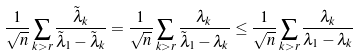Convert formula to latex. <formula><loc_0><loc_0><loc_500><loc_500>\frac { 1 } { \sqrt { n } } \sum _ { k > r } \frac { \tilde { \lambda } _ { k } } { \tilde { \lambda } _ { 1 } - \tilde { \lambda } _ { k } } = \frac { 1 } { \sqrt { n } } \sum _ { k > r } \frac { \lambda _ { k } } { \tilde { \lambda } _ { 1 } - \lambda _ { k } } \leq \frac { 1 } { \sqrt { n } } \sum _ { k > r } \frac { \lambda _ { k } } { \lambda _ { 1 } - \lambda _ { k } }</formula> 